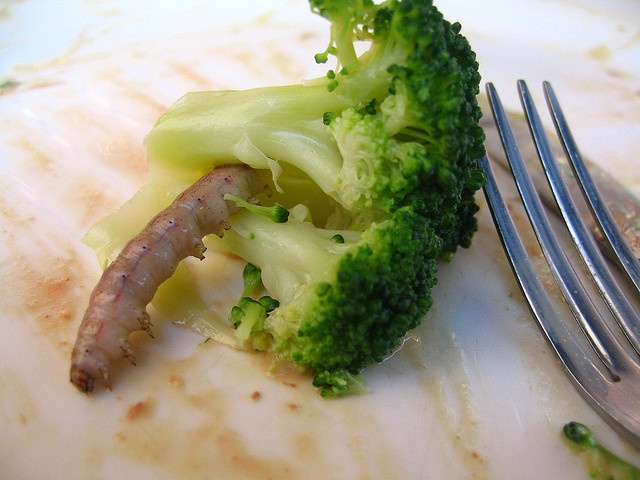Describe the objects in this image and their specific colors. I can see broccoli in lightgray, black, olive, and darkgreen tones and fork in lightgray, gray, darkgray, and blue tones in this image. 